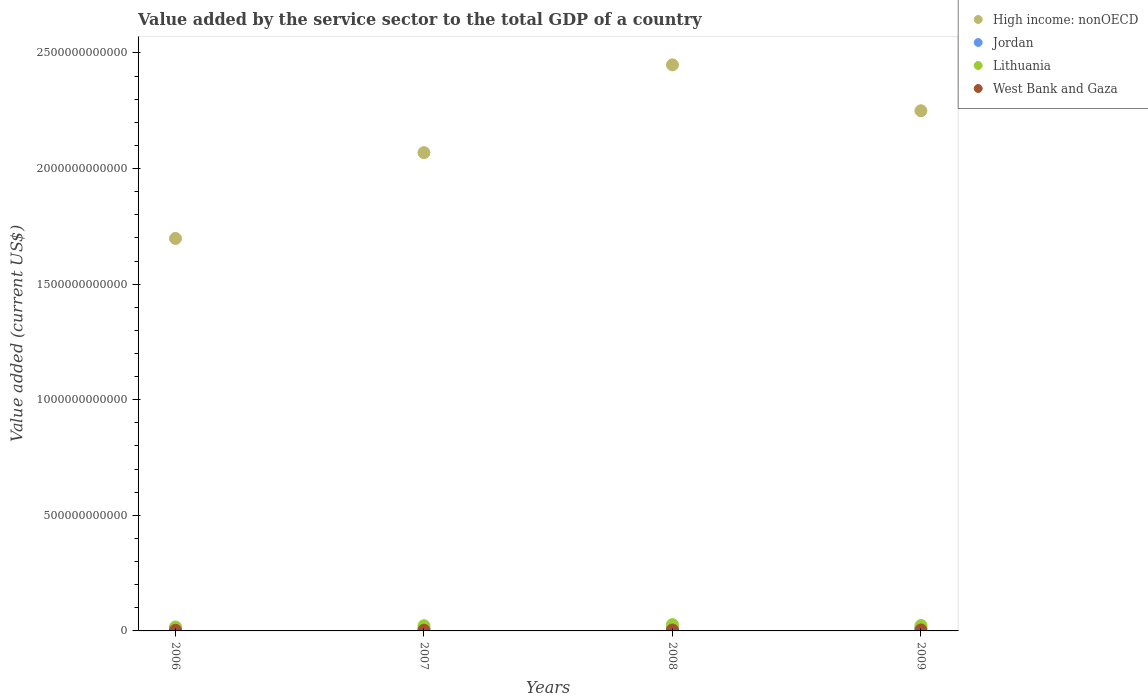How many different coloured dotlines are there?
Provide a succinct answer. 4. What is the value added by the service sector to the total GDP in Jordan in 2006?
Provide a succinct answer. 8.99e+09. Across all years, what is the maximum value added by the service sector to the total GDP in West Bank and Gaza?
Offer a terse response. 4.24e+09. Across all years, what is the minimum value added by the service sector to the total GDP in High income: nonOECD?
Your response must be concise. 1.70e+12. In which year was the value added by the service sector to the total GDP in High income: nonOECD minimum?
Provide a short and direct response. 2006. What is the total value added by the service sector to the total GDP in Lithuania in the graph?
Offer a terse response. 9.05e+1. What is the difference between the value added by the service sector to the total GDP in Jordan in 2006 and that in 2008?
Make the answer very short. -3.50e+09. What is the difference between the value added by the service sector to the total GDP in West Bank and Gaza in 2006 and the value added by the service sector to the total GDP in High income: nonOECD in 2007?
Your answer should be compact. -2.07e+12. What is the average value added by the service sector to the total GDP in Lithuania per year?
Your answer should be very brief. 2.26e+1. In the year 2006, what is the difference between the value added by the service sector to the total GDP in Lithuania and value added by the service sector to the total GDP in High income: nonOECD?
Keep it short and to the point. -1.68e+12. What is the ratio of the value added by the service sector to the total GDP in Lithuania in 2006 to that in 2008?
Give a very brief answer. 0.62. What is the difference between the highest and the second highest value added by the service sector to the total GDP in Lithuania?
Make the answer very short. 3.97e+09. What is the difference between the highest and the lowest value added by the service sector to the total GDP in West Bank and Gaza?
Provide a short and direct response. 1.27e+09. Is it the case that in every year, the sum of the value added by the service sector to the total GDP in Lithuania and value added by the service sector to the total GDP in High income: nonOECD  is greater than the value added by the service sector to the total GDP in Jordan?
Give a very brief answer. Yes. Does the value added by the service sector to the total GDP in Jordan monotonically increase over the years?
Give a very brief answer. Yes. How many dotlines are there?
Provide a succinct answer. 4. How many years are there in the graph?
Provide a short and direct response. 4. What is the difference between two consecutive major ticks on the Y-axis?
Provide a short and direct response. 5.00e+11. Where does the legend appear in the graph?
Offer a terse response. Top right. How are the legend labels stacked?
Offer a terse response. Vertical. What is the title of the graph?
Provide a succinct answer. Value added by the service sector to the total GDP of a country. Does "Portugal" appear as one of the legend labels in the graph?
Provide a short and direct response. No. What is the label or title of the X-axis?
Offer a very short reply. Years. What is the label or title of the Y-axis?
Provide a short and direct response. Value added (current US$). What is the Value added (current US$) in High income: nonOECD in 2006?
Your answer should be compact. 1.70e+12. What is the Value added (current US$) of Jordan in 2006?
Ensure brevity in your answer.  8.99e+09. What is the Value added (current US$) of Lithuania in 2006?
Make the answer very short. 1.70e+1. What is the Value added (current US$) in West Bank and Gaza in 2006?
Your response must be concise. 2.97e+09. What is the Value added (current US$) in High income: nonOECD in 2007?
Your answer should be compact. 2.07e+12. What is the Value added (current US$) of Jordan in 2007?
Offer a very short reply. 9.99e+09. What is the Value added (current US$) in Lithuania in 2007?
Make the answer very short. 2.25e+1. What is the Value added (current US$) of West Bank and Gaza in 2007?
Your answer should be very brief. 3.29e+09. What is the Value added (current US$) of High income: nonOECD in 2008?
Ensure brevity in your answer.  2.45e+12. What is the Value added (current US$) of Jordan in 2008?
Make the answer very short. 1.25e+1. What is the Value added (current US$) of Lithuania in 2008?
Make the answer very short. 2.74e+1. What is the Value added (current US$) in West Bank and Gaza in 2008?
Your answer should be compact. 3.89e+09. What is the Value added (current US$) in High income: nonOECD in 2009?
Keep it short and to the point. 2.25e+12. What is the Value added (current US$) of Jordan in 2009?
Offer a terse response. 1.37e+1. What is the Value added (current US$) of Lithuania in 2009?
Your answer should be compact. 2.34e+1. What is the Value added (current US$) of West Bank and Gaza in 2009?
Provide a succinct answer. 4.24e+09. Across all years, what is the maximum Value added (current US$) in High income: nonOECD?
Provide a succinct answer. 2.45e+12. Across all years, what is the maximum Value added (current US$) in Jordan?
Provide a succinct answer. 1.37e+1. Across all years, what is the maximum Value added (current US$) in Lithuania?
Your answer should be compact. 2.74e+1. Across all years, what is the maximum Value added (current US$) in West Bank and Gaza?
Keep it short and to the point. 4.24e+09. Across all years, what is the minimum Value added (current US$) in High income: nonOECD?
Provide a succinct answer. 1.70e+12. Across all years, what is the minimum Value added (current US$) in Jordan?
Give a very brief answer. 8.99e+09. Across all years, what is the minimum Value added (current US$) of Lithuania?
Give a very brief answer. 1.70e+1. Across all years, what is the minimum Value added (current US$) in West Bank and Gaza?
Offer a terse response. 2.97e+09. What is the total Value added (current US$) of High income: nonOECD in the graph?
Your response must be concise. 8.46e+12. What is the total Value added (current US$) of Jordan in the graph?
Your answer should be very brief. 4.52e+1. What is the total Value added (current US$) in Lithuania in the graph?
Keep it short and to the point. 9.05e+1. What is the total Value added (current US$) in West Bank and Gaza in the graph?
Your answer should be compact. 1.44e+1. What is the difference between the Value added (current US$) of High income: nonOECD in 2006 and that in 2007?
Offer a terse response. -3.71e+11. What is the difference between the Value added (current US$) of Jordan in 2006 and that in 2007?
Offer a terse response. -9.99e+08. What is the difference between the Value added (current US$) of Lithuania in 2006 and that in 2007?
Your response must be concise. -5.50e+09. What is the difference between the Value added (current US$) of West Bank and Gaza in 2006 and that in 2007?
Ensure brevity in your answer.  -3.26e+08. What is the difference between the Value added (current US$) in High income: nonOECD in 2006 and that in 2008?
Your answer should be compact. -7.51e+11. What is the difference between the Value added (current US$) of Jordan in 2006 and that in 2008?
Keep it short and to the point. -3.50e+09. What is the difference between the Value added (current US$) of Lithuania in 2006 and that in 2008?
Ensure brevity in your answer.  -1.04e+1. What is the difference between the Value added (current US$) of West Bank and Gaza in 2006 and that in 2008?
Provide a short and direct response. -9.17e+08. What is the difference between the Value added (current US$) in High income: nonOECD in 2006 and that in 2009?
Your answer should be compact. -5.52e+11. What is the difference between the Value added (current US$) in Jordan in 2006 and that in 2009?
Ensure brevity in your answer.  -4.76e+09. What is the difference between the Value added (current US$) in Lithuania in 2006 and that in 2009?
Keep it short and to the point. -6.41e+09. What is the difference between the Value added (current US$) in West Bank and Gaza in 2006 and that in 2009?
Provide a succinct answer. -1.27e+09. What is the difference between the Value added (current US$) of High income: nonOECD in 2007 and that in 2008?
Provide a succinct answer. -3.80e+11. What is the difference between the Value added (current US$) in Jordan in 2007 and that in 2008?
Provide a succinct answer. -2.50e+09. What is the difference between the Value added (current US$) in Lithuania in 2007 and that in 2008?
Your response must be concise. -4.87e+09. What is the difference between the Value added (current US$) in West Bank and Gaza in 2007 and that in 2008?
Your answer should be very brief. -5.92e+08. What is the difference between the Value added (current US$) in High income: nonOECD in 2007 and that in 2009?
Give a very brief answer. -1.81e+11. What is the difference between the Value added (current US$) of Jordan in 2007 and that in 2009?
Offer a terse response. -3.76e+09. What is the difference between the Value added (current US$) of Lithuania in 2007 and that in 2009?
Provide a short and direct response. -9.04e+08. What is the difference between the Value added (current US$) of West Bank and Gaza in 2007 and that in 2009?
Give a very brief answer. -9.40e+08. What is the difference between the Value added (current US$) of High income: nonOECD in 2008 and that in 2009?
Your response must be concise. 1.99e+11. What is the difference between the Value added (current US$) in Jordan in 2008 and that in 2009?
Keep it short and to the point. -1.25e+09. What is the difference between the Value added (current US$) of Lithuania in 2008 and that in 2009?
Ensure brevity in your answer.  3.97e+09. What is the difference between the Value added (current US$) in West Bank and Gaza in 2008 and that in 2009?
Your answer should be very brief. -3.49e+08. What is the difference between the Value added (current US$) of High income: nonOECD in 2006 and the Value added (current US$) of Jordan in 2007?
Offer a very short reply. 1.69e+12. What is the difference between the Value added (current US$) of High income: nonOECD in 2006 and the Value added (current US$) of Lithuania in 2007?
Offer a terse response. 1.68e+12. What is the difference between the Value added (current US$) in High income: nonOECD in 2006 and the Value added (current US$) in West Bank and Gaza in 2007?
Provide a succinct answer. 1.69e+12. What is the difference between the Value added (current US$) of Jordan in 2006 and the Value added (current US$) of Lithuania in 2007?
Provide a short and direct response. -1.36e+1. What is the difference between the Value added (current US$) of Jordan in 2006 and the Value added (current US$) of West Bank and Gaza in 2007?
Provide a short and direct response. 5.69e+09. What is the difference between the Value added (current US$) of Lithuania in 2006 and the Value added (current US$) of West Bank and Gaza in 2007?
Provide a succinct answer. 1.37e+1. What is the difference between the Value added (current US$) of High income: nonOECD in 2006 and the Value added (current US$) of Jordan in 2008?
Your response must be concise. 1.69e+12. What is the difference between the Value added (current US$) of High income: nonOECD in 2006 and the Value added (current US$) of Lithuania in 2008?
Provide a short and direct response. 1.67e+12. What is the difference between the Value added (current US$) in High income: nonOECD in 2006 and the Value added (current US$) in West Bank and Gaza in 2008?
Offer a terse response. 1.69e+12. What is the difference between the Value added (current US$) of Jordan in 2006 and the Value added (current US$) of Lithuania in 2008?
Provide a succinct answer. -1.84e+1. What is the difference between the Value added (current US$) of Jordan in 2006 and the Value added (current US$) of West Bank and Gaza in 2008?
Offer a terse response. 5.10e+09. What is the difference between the Value added (current US$) of Lithuania in 2006 and the Value added (current US$) of West Bank and Gaza in 2008?
Offer a terse response. 1.32e+1. What is the difference between the Value added (current US$) in High income: nonOECD in 2006 and the Value added (current US$) in Jordan in 2009?
Your response must be concise. 1.68e+12. What is the difference between the Value added (current US$) in High income: nonOECD in 2006 and the Value added (current US$) in Lithuania in 2009?
Give a very brief answer. 1.67e+12. What is the difference between the Value added (current US$) of High income: nonOECD in 2006 and the Value added (current US$) of West Bank and Gaza in 2009?
Offer a terse response. 1.69e+12. What is the difference between the Value added (current US$) in Jordan in 2006 and the Value added (current US$) in Lithuania in 2009?
Ensure brevity in your answer.  -1.45e+1. What is the difference between the Value added (current US$) of Jordan in 2006 and the Value added (current US$) of West Bank and Gaza in 2009?
Your response must be concise. 4.75e+09. What is the difference between the Value added (current US$) of Lithuania in 2006 and the Value added (current US$) of West Bank and Gaza in 2009?
Your answer should be very brief. 1.28e+1. What is the difference between the Value added (current US$) in High income: nonOECD in 2007 and the Value added (current US$) in Jordan in 2008?
Ensure brevity in your answer.  2.06e+12. What is the difference between the Value added (current US$) of High income: nonOECD in 2007 and the Value added (current US$) of Lithuania in 2008?
Keep it short and to the point. 2.04e+12. What is the difference between the Value added (current US$) in High income: nonOECD in 2007 and the Value added (current US$) in West Bank and Gaza in 2008?
Your answer should be very brief. 2.06e+12. What is the difference between the Value added (current US$) of Jordan in 2007 and the Value added (current US$) of Lithuania in 2008?
Give a very brief answer. -1.74e+1. What is the difference between the Value added (current US$) of Jordan in 2007 and the Value added (current US$) of West Bank and Gaza in 2008?
Give a very brief answer. 6.10e+09. What is the difference between the Value added (current US$) of Lithuania in 2007 and the Value added (current US$) of West Bank and Gaza in 2008?
Make the answer very short. 1.87e+1. What is the difference between the Value added (current US$) in High income: nonOECD in 2007 and the Value added (current US$) in Jordan in 2009?
Your answer should be compact. 2.06e+12. What is the difference between the Value added (current US$) in High income: nonOECD in 2007 and the Value added (current US$) in Lithuania in 2009?
Your answer should be very brief. 2.05e+12. What is the difference between the Value added (current US$) of High income: nonOECD in 2007 and the Value added (current US$) of West Bank and Gaza in 2009?
Your response must be concise. 2.06e+12. What is the difference between the Value added (current US$) of Jordan in 2007 and the Value added (current US$) of Lithuania in 2009?
Your answer should be very brief. -1.35e+1. What is the difference between the Value added (current US$) of Jordan in 2007 and the Value added (current US$) of West Bank and Gaza in 2009?
Ensure brevity in your answer.  5.75e+09. What is the difference between the Value added (current US$) in Lithuania in 2007 and the Value added (current US$) in West Bank and Gaza in 2009?
Offer a terse response. 1.83e+1. What is the difference between the Value added (current US$) in High income: nonOECD in 2008 and the Value added (current US$) in Jordan in 2009?
Your response must be concise. 2.43e+12. What is the difference between the Value added (current US$) of High income: nonOECD in 2008 and the Value added (current US$) of Lithuania in 2009?
Offer a very short reply. 2.43e+12. What is the difference between the Value added (current US$) in High income: nonOECD in 2008 and the Value added (current US$) in West Bank and Gaza in 2009?
Offer a very short reply. 2.44e+12. What is the difference between the Value added (current US$) in Jordan in 2008 and the Value added (current US$) in Lithuania in 2009?
Provide a short and direct response. -1.10e+1. What is the difference between the Value added (current US$) in Jordan in 2008 and the Value added (current US$) in West Bank and Gaza in 2009?
Give a very brief answer. 8.26e+09. What is the difference between the Value added (current US$) in Lithuania in 2008 and the Value added (current US$) in West Bank and Gaza in 2009?
Make the answer very short. 2.32e+1. What is the average Value added (current US$) of High income: nonOECD per year?
Offer a very short reply. 2.12e+12. What is the average Value added (current US$) of Jordan per year?
Your answer should be very brief. 1.13e+1. What is the average Value added (current US$) in Lithuania per year?
Keep it short and to the point. 2.26e+1. What is the average Value added (current US$) in West Bank and Gaza per year?
Provide a succinct answer. 3.60e+09. In the year 2006, what is the difference between the Value added (current US$) in High income: nonOECD and Value added (current US$) in Jordan?
Your response must be concise. 1.69e+12. In the year 2006, what is the difference between the Value added (current US$) of High income: nonOECD and Value added (current US$) of Lithuania?
Your response must be concise. 1.68e+12. In the year 2006, what is the difference between the Value added (current US$) in High income: nonOECD and Value added (current US$) in West Bank and Gaza?
Ensure brevity in your answer.  1.69e+12. In the year 2006, what is the difference between the Value added (current US$) of Jordan and Value added (current US$) of Lithuania?
Give a very brief answer. -8.05e+09. In the year 2006, what is the difference between the Value added (current US$) in Jordan and Value added (current US$) in West Bank and Gaza?
Keep it short and to the point. 6.02e+09. In the year 2006, what is the difference between the Value added (current US$) in Lithuania and Value added (current US$) in West Bank and Gaza?
Provide a succinct answer. 1.41e+1. In the year 2007, what is the difference between the Value added (current US$) in High income: nonOECD and Value added (current US$) in Jordan?
Make the answer very short. 2.06e+12. In the year 2007, what is the difference between the Value added (current US$) of High income: nonOECD and Value added (current US$) of Lithuania?
Keep it short and to the point. 2.05e+12. In the year 2007, what is the difference between the Value added (current US$) in High income: nonOECD and Value added (current US$) in West Bank and Gaza?
Keep it short and to the point. 2.07e+12. In the year 2007, what is the difference between the Value added (current US$) in Jordan and Value added (current US$) in Lithuania?
Give a very brief answer. -1.26e+1. In the year 2007, what is the difference between the Value added (current US$) of Jordan and Value added (current US$) of West Bank and Gaza?
Keep it short and to the point. 6.69e+09. In the year 2007, what is the difference between the Value added (current US$) in Lithuania and Value added (current US$) in West Bank and Gaza?
Ensure brevity in your answer.  1.93e+1. In the year 2008, what is the difference between the Value added (current US$) in High income: nonOECD and Value added (current US$) in Jordan?
Your response must be concise. 2.44e+12. In the year 2008, what is the difference between the Value added (current US$) in High income: nonOECD and Value added (current US$) in Lithuania?
Offer a terse response. 2.42e+12. In the year 2008, what is the difference between the Value added (current US$) of High income: nonOECD and Value added (current US$) of West Bank and Gaza?
Keep it short and to the point. 2.44e+12. In the year 2008, what is the difference between the Value added (current US$) of Jordan and Value added (current US$) of Lithuania?
Give a very brief answer. -1.49e+1. In the year 2008, what is the difference between the Value added (current US$) of Jordan and Value added (current US$) of West Bank and Gaza?
Your answer should be very brief. 8.61e+09. In the year 2008, what is the difference between the Value added (current US$) of Lithuania and Value added (current US$) of West Bank and Gaza?
Your answer should be compact. 2.35e+1. In the year 2009, what is the difference between the Value added (current US$) of High income: nonOECD and Value added (current US$) of Jordan?
Give a very brief answer. 2.24e+12. In the year 2009, what is the difference between the Value added (current US$) in High income: nonOECD and Value added (current US$) in Lithuania?
Offer a terse response. 2.23e+12. In the year 2009, what is the difference between the Value added (current US$) of High income: nonOECD and Value added (current US$) of West Bank and Gaza?
Your response must be concise. 2.25e+12. In the year 2009, what is the difference between the Value added (current US$) of Jordan and Value added (current US$) of Lithuania?
Offer a very short reply. -9.70e+09. In the year 2009, what is the difference between the Value added (current US$) of Jordan and Value added (current US$) of West Bank and Gaza?
Offer a terse response. 9.51e+09. In the year 2009, what is the difference between the Value added (current US$) in Lithuania and Value added (current US$) in West Bank and Gaza?
Your answer should be compact. 1.92e+1. What is the ratio of the Value added (current US$) of High income: nonOECD in 2006 to that in 2007?
Make the answer very short. 0.82. What is the ratio of the Value added (current US$) in Jordan in 2006 to that in 2007?
Give a very brief answer. 0.9. What is the ratio of the Value added (current US$) of Lithuania in 2006 to that in 2007?
Offer a very short reply. 0.76. What is the ratio of the Value added (current US$) in West Bank and Gaza in 2006 to that in 2007?
Ensure brevity in your answer.  0.9. What is the ratio of the Value added (current US$) in High income: nonOECD in 2006 to that in 2008?
Keep it short and to the point. 0.69. What is the ratio of the Value added (current US$) of Jordan in 2006 to that in 2008?
Your answer should be very brief. 0.72. What is the ratio of the Value added (current US$) of Lithuania in 2006 to that in 2008?
Offer a very short reply. 0.62. What is the ratio of the Value added (current US$) in West Bank and Gaza in 2006 to that in 2008?
Your answer should be compact. 0.76. What is the ratio of the Value added (current US$) of High income: nonOECD in 2006 to that in 2009?
Your answer should be very brief. 0.75. What is the ratio of the Value added (current US$) in Jordan in 2006 to that in 2009?
Ensure brevity in your answer.  0.65. What is the ratio of the Value added (current US$) of Lithuania in 2006 to that in 2009?
Offer a terse response. 0.73. What is the ratio of the Value added (current US$) of West Bank and Gaza in 2006 to that in 2009?
Your answer should be very brief. 0.7. What is the ratio of the Value added (current US$) in High income: nonOECD in 2007 to that in 2008?
Offer a terse response. 0.84. What is the ratio of the Value added (current US$) in Jordan in 2007 to that in 2008?
Offer a very short reply. 0.8. What is the ratio of the Value added (current US$) in Lithuania in 2007 to that in 2008?
Your answer should be compact. 0.82. What is the ratio of the Value added (current US$) of West Bank and Gaza in 2007 to that in 2008?
Make the answer very short. 0.85. What is the ratio of the Value added (current US$) of High income: nonOECD in 2007 to that in 2009?
Provide a succinct answer. 0.92. What is the ratio of the Value added (current US$) of Jordan in 2007 to that in 2009?
Provide a succinct answer. 0.73. What is the ratio of the Value added (current US$) in Lithuania in 2007 to that in 2009?
Keep it short and to the point. 0.96. What is the ratio of the Value added (current US$) of West Bank and Gaza in 2007 to that in 2009?
Offer a terse response. 0.78. What is the ratio of the Value added (current US$) of High income: nonOECD in 2008 to that in 2009?
Provide a succinct answer. 1.09. What is the ratio of the Value added (current US$) in Jordan in 2008 to that in 2009?
Make the answer very short. 0.91. What is the ratio of the Value added (current US$) in Lithuania in 2008 to that in 2009?
Keep it short and to the point. 1.17. What is the ratio of the Value added (current US$) in West Bank and Gaza in 2008 to that in 2009?
Provide a succinct answer. 0.92. What is the difference between the highest and the second highest Value added (current US$) of High income: nonOECD?
Your answer should be very brief. 1.99e+11. What is the difference between the highest and the second highest Value added (current US$) in Jordan?
Offer a terse response. 1.25e+09. What is the difference between the highest and the second highest Value added (current US$) in Lithuania?
Give a very brief answer. 3.97e+09. What is the difference between the highest and the second highest Value added (current US$) of West Bank and Gaza?
Ensure brevity in your answer.  3.49e+08. What is the difference between the highest and the lowest Value added (current US$) in High income: nonOECD?
Ensure brevity in your answer.  7.51e+11. What is the difference between the highest and the lowest Value added (current US$) of Jordan?
Provide a succinct answer. 4.76e+09. What is the difference between the highest and the lowest Value added (current US$) in Lithuania?
Give a very brief answer. 1.04e+1. What is the difference between the highest and the lowest Value added (current US$) in West Bank and Gaza?
Give a very brief answer. 1.27e+09. 